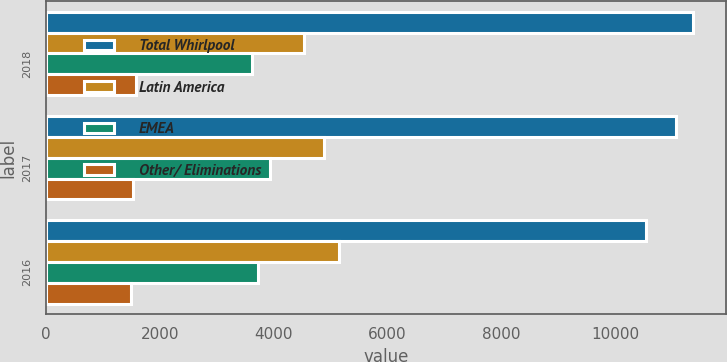Convert chart. <chart><loc_0><loc_0><loc_500><loc_500><stacked_bar_chart><ecel><fcel>2018<fcel>2017<fcel>2016<nl><fcel>Total Whirlpool<fcel>11374<fcel>11065<fcel>10541<nl><fcel>Latin America<fcel>4536<fcel>4881<fcel>5148<nl><fcel>EMEA<fcel>3618<fcel>3946<fcel>3731<nl><fcel>Other/ Eliminations<fcel>1587<fcel>1539<fcel>1490<nl></chart> 